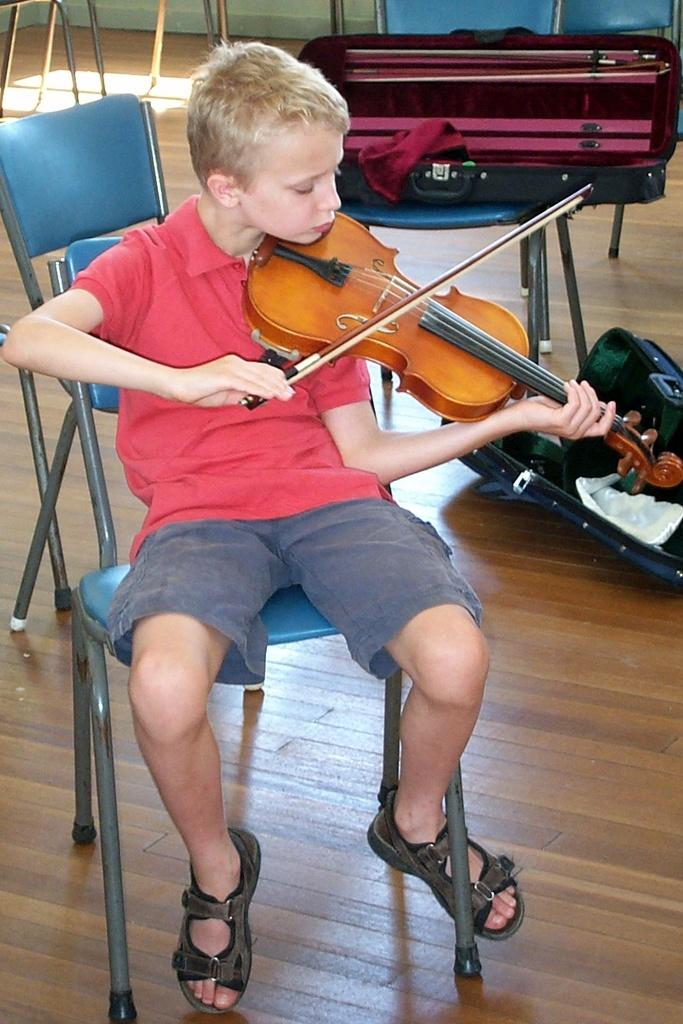Where is the setting of the image? The image is inside a room. Who is present in the image? There is a boy in the image. What is the boy doing in the image? The boy is sitting on a chair and playing the violin. Are there any other chairs in the image? Yes, there is another chair in the image. What is on the other chair? There are suitcases on the chair. Can you see any windows in the image? There is no mention of a window in the provided facts, so we cannot determine if there is a window in the image. Is there a van parked outside the room in the image? There is no information about a van or any outdoor elements in the provided facts, so we cannot determine if there is a van in the image. 